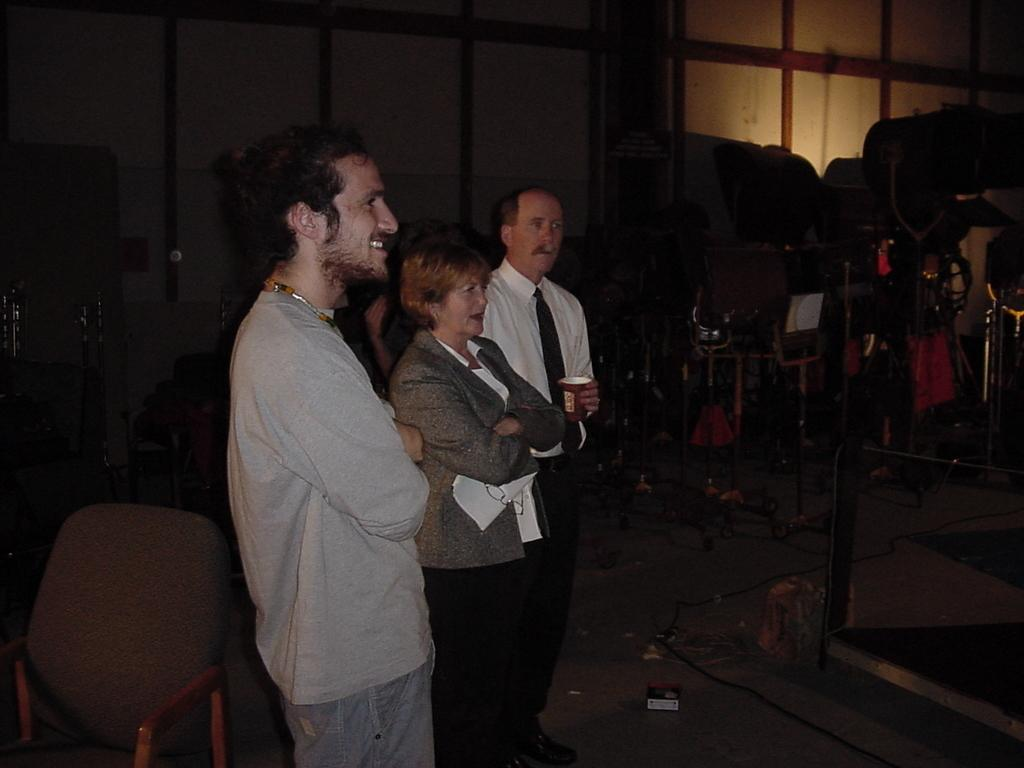How many people are in the image? There are three persons standing in the image. What is the surface they are standing on? The persons are standing on the floor. Are there any furniture items in the image? Yes, there are chairs in the image. What can be seen in the background of the image? There is a wall visible in the background of the image. What type of desk can be seen in the image? There is no desk present in the image. Are the three persons in the image related as brothers? The provided facts do not mention any familial relationships between the persons in the image. 